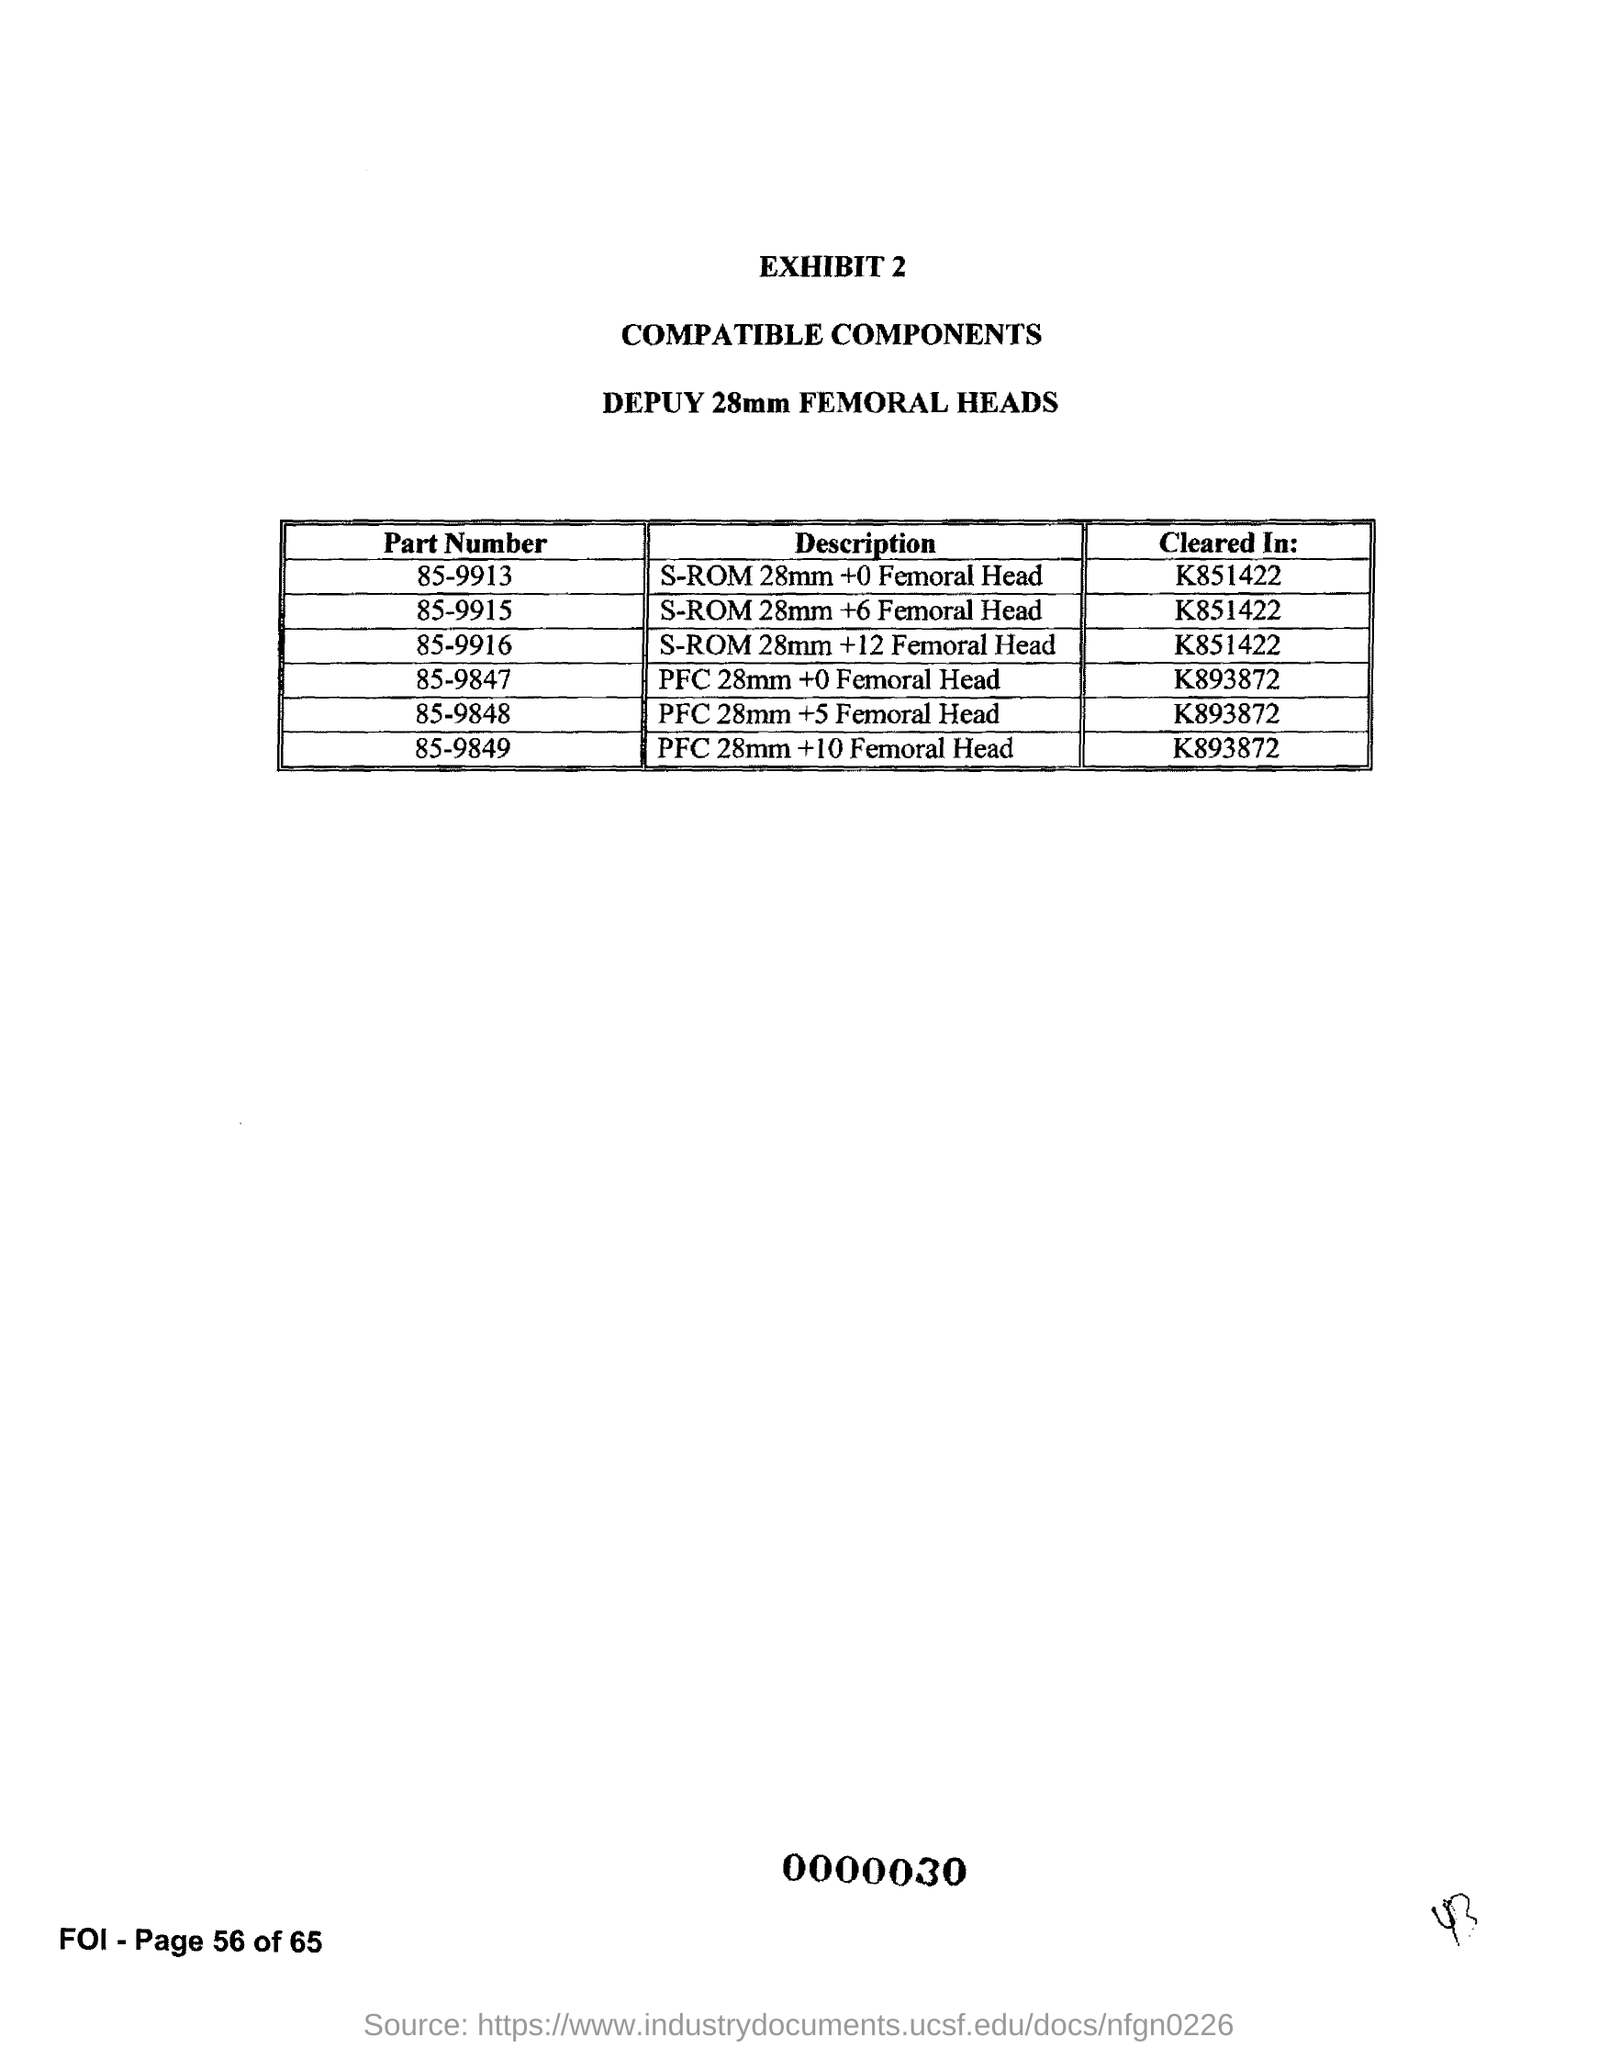Give some essential details in this illustration. The part number '85-9847' has been cleared in K893872. The part number "85-9915" has been cleared in the item number K851422. The part number 85-9915 is described as an S-ROM 28mm +6 Femoral Head. The cleared in value for part number - "85-9849" is K893872. The part number '85-9916' has been cleared in K851422. 